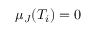Convert formula to latex. <formula><loc_0><loc_0><loc_500><loc_500>\mu _ { J } ( T _ { i } ) = 0</formula> 